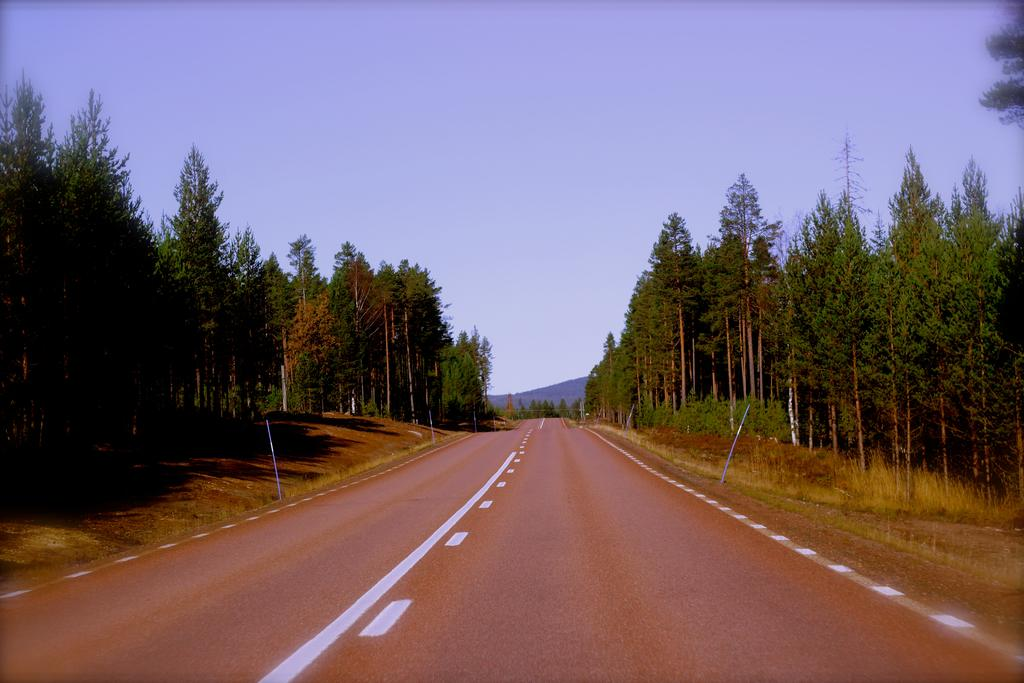What is the main feature of the image? There is a road in the image. What can be seen on the road? The road has white lines. Are there any structures along the road? Yes, there are poles along the road. What type of vegetation is visible in the image? There is grass and trees visible in the image. What is visible in the background of the image? The sky is visible in the background of the image. How many quarters can be seen on the road in the image? There are no quarters visible on the road in the image. Is there a prison visible in the image? There is no prison present in the image. 